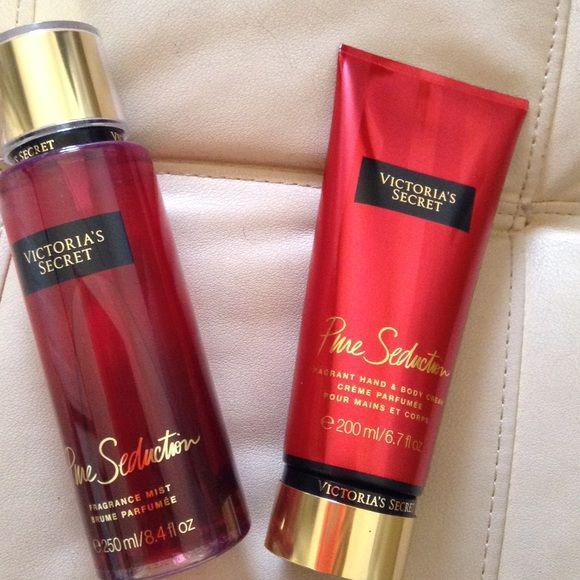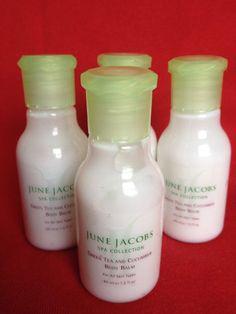The first image is the image on the left, the second image is the image on the right. Evaluate the accuracy of this statement regarding the images: "Each image shows the same number of skincare products.". Is it true? Answer yes or no. No. 